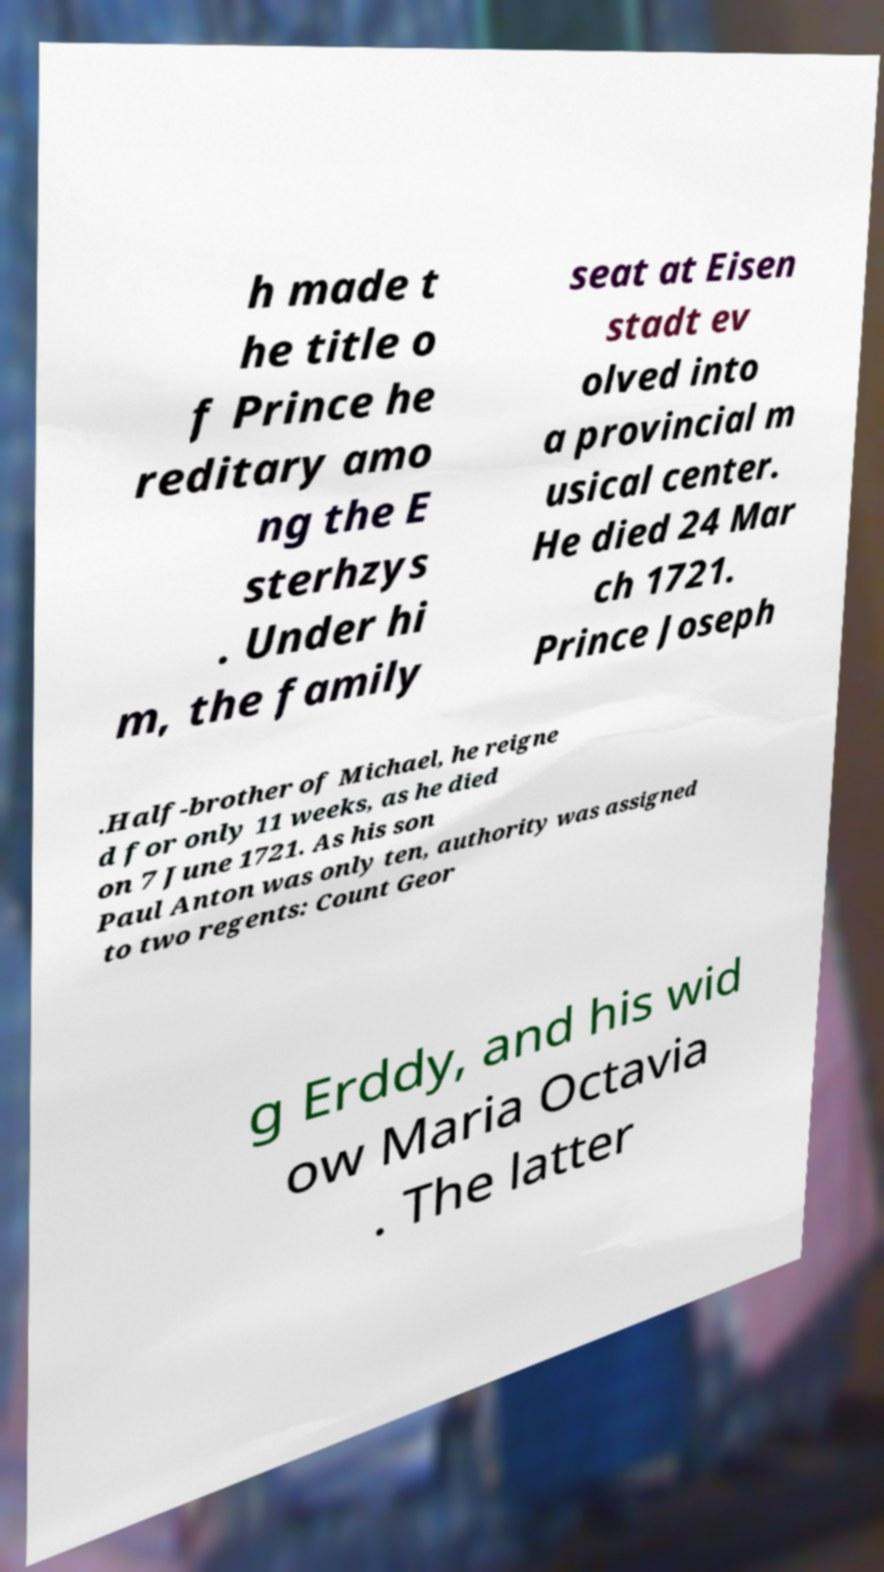There's text embedded in this image that I need extracted. Can you transcribe it verbatim? h made t he title o f Prince he reditary amo ng the E sterhzys . Under hi m, the family seat at Eisen stadt ev olved into a provincial m usical center. He died 24 Mar ch 1721. Prince Joseph .Half-brother of Michael, he reigne d for only 11 weeks, as he died on 7 June 1721. As his son Paul Anton was only ten, authority was assigned to two regents: Count Geor g Erddy, and his wid ow Maria Octavia . The latter 